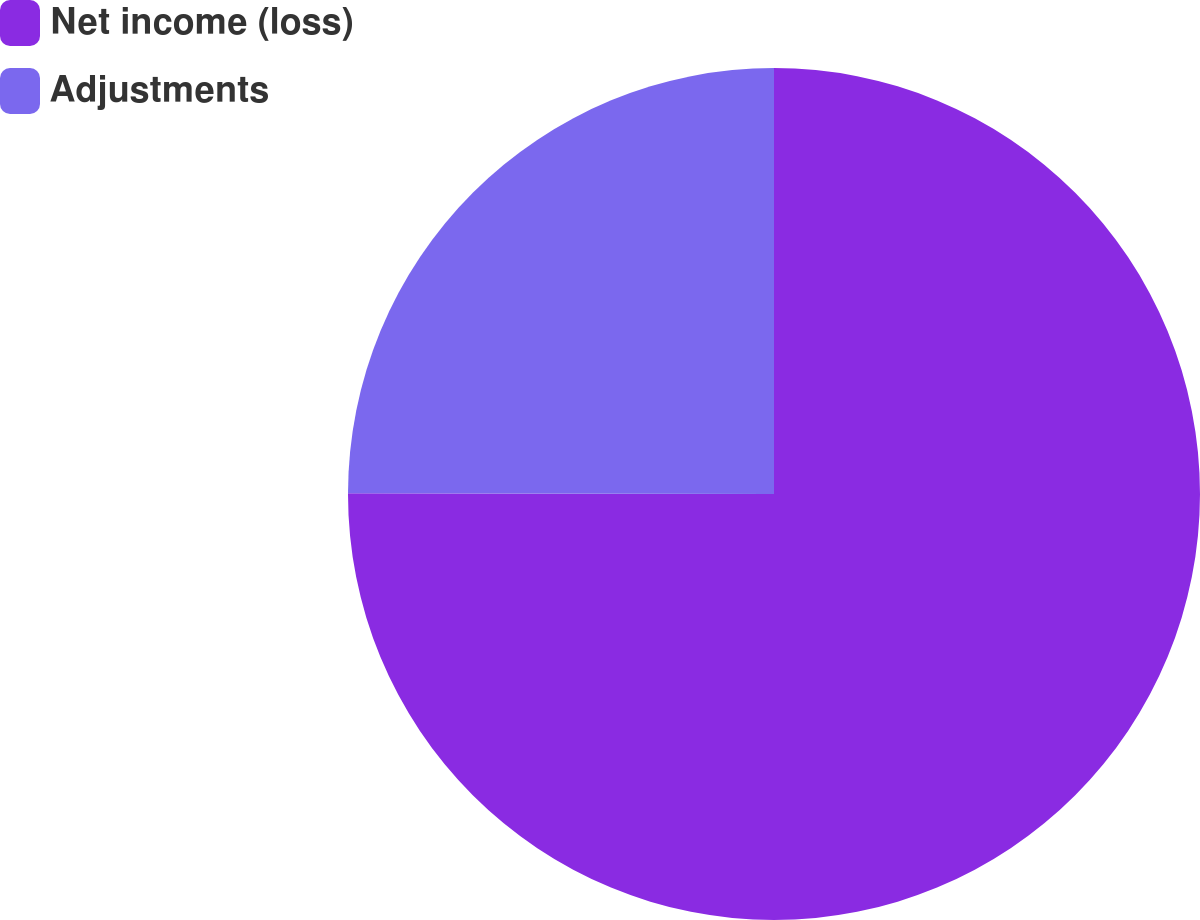<chart> <loc_0><loc_0><loc_500><loc_500><pie_chart><fcel>Net income (loss)<fcel>Adjustments<nl><fcel>75.03%<fcel>24.97%<nl></chart> 